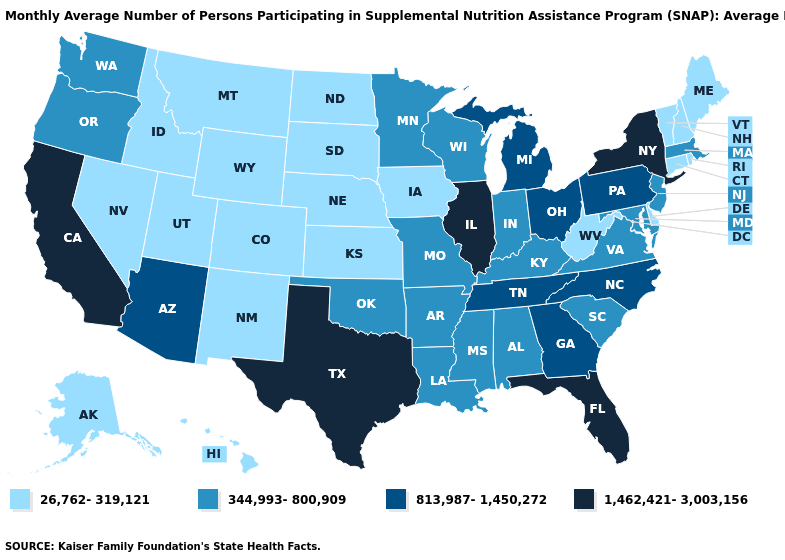Name the states that have a value in the range 813,987-1,450,272?
Short answer required. Arizona, Georgia, Michigan, North Carolina, Ohio, Pennsylvania, Tennessee. Does the first symbol in the legend represent the smallest category?
Write a very short answer. Yes. What is the lowest value in states that border Connecticut?
Short answer required. 26,762-319,121. Is the legend a continuous bar?
Short answer required. No. Which states hav the highest value in the MidWest?
Give a very brief answer. Illinois. Does the map have missing data?
Write a very short answer. No. Which states hav the highest value in the West?
Short answer required. California. Is the legend a continuous bar?
Write a very short answer. No. What is the value of New Hampshire?
Short answer required. 26,762-319,121. Name the states that have a value in the range 26,762-319,121?
Give a very brief answer. Alaska, Colorado, Connecticut, Delaware, Hawaii, Idaho, Iowa, Kansas, Maine, Montana, Nebraska, Nevada, New Hampshire, New Mexico, North Dakota, Rhode Island, South Dakota, Utah, Vermont, West Virginia, Wyoming. What is the value of Georgia?
Give a very brief answer. 813,987-1,450,272. Does Delaware have the same value as West Virginia?
Be succinct. Yes. Does Louisiana have a lower value than Texas?
Short answer required. Yes. Does Washington have the lowest value in the West?
Write a very short answer. No. What is the value of Michigan?
Keep it brief. 813,987-1,450,272. 